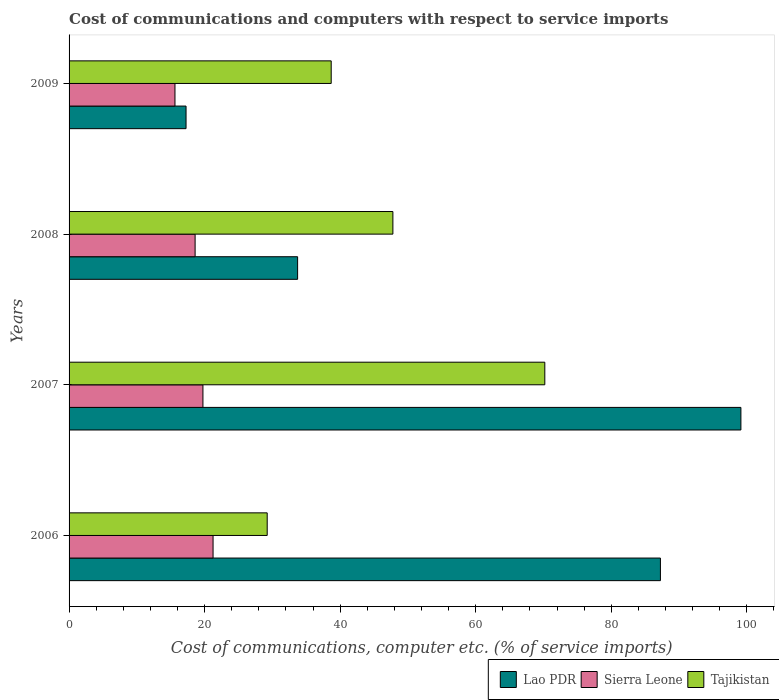How many different coloured bars are there?
Your answer should be compact. 3. Are the number of bars per tick equal to the number of legend labels?
Your answer should be compact. Yes. What is the label of the 4th group of bars from the top?
Provide a succinct answer. 2006. What is the cost of communications and computers in Sierra Leone in 2006?
Keep it short and to the point. 21.25. Across all years, what is the maximum cost of communications and computers in Tajikistan?
Your answer should be compact. 70.2. Across all years, what is the minimum cost of communications and computers in Sierra Leone?
Offer a very short reply. 15.63. In which year was the cost of communications and computers in Tajikistan minimum?
Offer a very short reply. 2006. What is the total cost of communications and computers in Lao PDR in the graph?
Your answer should be compact. 237.36. What is the difference between the cost of communications and computers in Tajikistan in 2006 and that in 2008?
Make the answer very short. -18.55. What is the difference between the cost of communications and computers in Lao PDR in 2006 and the cost of communications and computers in Sierra Leone in 2009?
Provide a short and direct response. 71.63. What is the average cost of communications and computers in Lao PDR per year?
Offer a terse response. 59.34. In the year 2006, what is the difference between the cost of communications and computers in Lao PDR and cost of communications and computers in Sierra Leone?
Make the answer very short. 66.01. What is the ratio of the cost of communications and computers in Lao PDR in 2006 to that in 2008?
Give a very brief answer. 2.59. Is the cost of communications and computers in Tajikistan in 2006 less than that in 2008?
Your answer should be compact. Yes. What is the difference between the highest and the second highest cost of communications and computers in Tajikistan?
Your response must be concise. 22.42. What is the difference between the highest and the lowest cost of communications and computers in Sierra Leone?
Provide a short and direct response. 5.62. In how many years, is the cost of communications and computers in Tajikistan greater than the average cost of communications and computers in Tajikistan taken over all years?
Offer a terse response. 2. What does the 3rd bar from the top in 2009 represents?
Provide a short and direct response. Lao PDR. What does the 1st bar from the bottom in 2008 represents?
Provide a short and direct response. Lao PDR. Are all the bars in the graph horizontal?
Offer a terse response. Yes. How many years are there in the graph?
Provide a short and direct response. 4. Does the graph contain any zero values?
Make the answer very short. No. Does the graph contain grids?
Provide a succinct answer. No. How many legend labels are there?
Provide a short and direct response. 3. What is the title of the graph?
Your answer should be very brief. Cost of communications and computers with respect to service imports. Does "Heavily indebted poor countries" appear as one of the legend labels in the graph?
Offer a very short reply. No. What is the label or title of the X-axis?
Offer a very short reply. Cost of communications, computer etc. (% of service imports). What is the Cost of communications, computer etc. (% of service imports) of Lao PDR in 2006?
Your response must be concise. 87.25. What is the Cost of communications, computer etc. (% of service imports) of Sierra Leone in 2006?
Your answer should be very brief. 21.25. What is the Cost of communications, computer etc. (% of service imports) in Tajikistan in 2006?
Your response must be concise. 29.23. What is the Cost of communications, computer etc. (% of service imports) of Lao PDR in 2007?
Offer a very short reply. 99.13. What is the Cost of communications, computer etc. (% of service imports) in Sierra Leone in 2007?
Provide a succinct answer. 19.75. What is the Cost of communications, computer etc. (% of service imports) in Tajikistan in 2007?
Your response must be concise. 70.2. What is the Cost of communications, computer etc. (% of service imports) of Lao PDR in 2008?
Ensure brevity in your answer.  33.72. What is the Cost of communications, computer etc. (% of service imports) in Sierra Leone in 2008?
Your answer should be compact. 18.6. What is the Cost of communications, computer etc. (% of service imports) in Tajikistan in 2008?
Offer a very short reply. 47.78. What is the Cost of communications, computer etc. (% of service imports) in Lao PDR in 2009?
Your response must be concise. 17.26. What is the Cost of communications, computer etc. (% of service imports) in Sierra Leone in 2009?
Provide a short and direct response. 15.63. What is the Cost of communications, computer etc. (% of service imports) in Tajikistan in 2009?
Offer a very short reply. 38.68. Across all years, what is the maximum Cost of communications, computer etc. (% of service imports) in Lao PDR?
Ensure brevity in your answer.  99.13. Across all years, what is the maximum Cost of communications, computer etc. (% of service imports) in Sierra Leone?
Offer a terse response. 21.25. Across all years, what is the maximum Cost of communications, computer etc. (% of service imports) of Tajikistan?
Your response must be concise. 70.2. Across all years, what is the minimum Cost of communications, computer etc. (% of service imports) of Lao PDR?
Make the answer very short. 17.26. Across all years, what is the minimum Cost of communications, computer etc. (% of service imports) of Sierra Leone?
Keep it short and to the point. 15.63. Across all years, what is the minimum Cost of communications, computer etc. (% of service imports) in Tajikistan?
Make the answer very short. 29.23. What is the total Cost of communications, computer etc. (% of service imports) in Lao PDR in the graph?
Offer a terse response. 237.36. What is the total Cost of communications, computer etc. (% of service imports) of Sierra Leone in the graph?
Give a very brief answer. 75.22. What is the total Cost of communications, computer etc. (% of service imports) in Tajikistan in the graph?
Your answer should be very brief. 185.89. What is the difference between the Cost of communications, computer etc. (% of service imports) in Lao PDR in 2006 and that in 2007?
Make the answer very short. -11.88. What is the difference between the Cost of communications, computer etc. (% of service imports) of Sierra Leone in 2006 and that in 2007?
Provide a short and direct response. 1.49. What is the difference between the Cost of communications, computer etc. (% of service imports) of Tajikistan in 2006 and that in 2007?
Your answer should be very brief. -40.96. What is the difference between the Cost of communications, computer etc. (% of service imports) in Lao PDR in 2006 and that in 2008?
Give a very brief answer. 53.53. What is the difference between the Cost of communications, computer etc. (% of service imports) of Sierra Leone in 2006 and that in 2008?
Your answer should be compact. 2.65. What is the difference between the Cost of communications, computer etc. (% of service imports) in Tajikistan in 2006 and that in 2008?
Offer a very short reply. -18.55. What is the difference between the Cost of communications, computer etc. (% of service imports) of Lao PDR in 2006 and that in 2009?
Your response must be concise. 69.99. What is the difference between the Cost of communications, computer etc. (% of service imports) of Sierra Leone in 2006 and that in 2009?
Your answer should be very brief. 5.62. What is the difference between the Cost of communications, computer etc. (% of service imports) of Tajikistan in 2006 and that in 2009?
Give a very brief answer. -9.44. What is the difference between the Cost of communications, computer etc. (% of service imports) of Lao PDR in 2007 and that in 2008?
Ensure brevity in your answer.  65.41. What is the difference between the Cost of communications, computer etc. (% of service imports) of Sierra Leone in 2007 and that in 2008?
Your answer should be compact. 1.16. What is the difference between the Cost of communications, computer etc. (% of service imports) in Tajikistan in 2007 and that in 2008?
Offer a terse response. 22.42. What is the difference between the Cost of communications, computer etc. (% of service imports) in Lao PDR in 2007 and that in 2009?
Your answer should be compact. 81.87. What is the difference between the Cost of communications, computer etc. (% of service imports) in Sierra Leone in 2007 and that in 2009?
Keep it short and to the point. 4.13. What is the difference between the Cost of communications, computer etc. (% of service imports) of Tajikistan in 2007 and that in 2009?
Keep it short and to the point. 31.52. What is the difference between the Cost of communications, computer etc. (% of service imports) of Lao PDR in 2008 and that in 2009?
Provide a short and direct response. 16.46. What is the difference between the Cost of communications, computer etc. (% of service imports) in Sierra Leone in 2008 and that in 2009?
Your response must be concise. 2.97. What is the difference between the Cost of communications, computer etc. (% of service imports) in Tajikistan in 2008 and that in 2009?
Provide a short and direct response. 9.1. What is the difference between the Cost of communications, computer etc. (% of service imports) in Lao PDR in 2006 and the Cost of communications, computer etc. (% of service imports) in Sierra Leone in 2007?
Provide a short and direct response. 67.5. What is the difference between the Cost of communications, computer etc. (% of service imports) of Lao PDR in 2006 and the Cost of communications, computer etc. (% of service imports) of Tajikistan in 2007?
Provide a succinct answer. 17.06. What is the difference between the Cost of communications, computer etc. (% of service imports) in Sierra Leone in 2006 and the Cost of communications, computer etc. (% of service imports) in Tajikistan in 2007?
Provide a short and direct response. -48.95. What is the difference between the Cost of communications, computer etc. (% of service imports) of Lao PDR in 2006 and the Cost of communications, computer etc. (% of service imports) of Sierra Leone in 2008?
Your answer should be compact. 68.66. What is the difference between the Cost of communications, computer etc. (% of service imports) of Lao PDR in 2006 and the Cost of communications, computer etc. (% of service imports) of Tajikistan in 2008?
Give a very brief answer. 39.47. What is the difference between the Cost of communications, computer etc. (% of service imports) in Sierra Leone in 2006 and the Cost of communications, computer etc. (% of service imports) in Tajikistan in 2008?
Make the answer very short. -26.53. What is the difference between the Cost of communications, computer etc. (% of service imports) of Lao PDR in 2006 and the Cost of communications, computer etc. (% of service imports) of Sierra Leone in 2009?
Offer a terse response. 71.63. What is the difference between the Cost of communications, computer etc. (% of service imports) of Lao PDR in 2006 and the Cost of communications, computer etc. (% of service imports) of Tajikistan in 2009?
Make the answer very short. 48.57. What is the difference between the Cost of communications, computer etc. (% of service imports) of Sierra Leone in 2006 and the Cost of communications, computer etc. (% of service imports) of Tajikistan in 2009?
Ensure brevity in your answer.  -17.43. What is the difference between the Cost of communications, computer etc. (% of service imports) in Lao PDR in 2007 and the Cost of communications, computer etc. (% of service imports) in Sierra Leone in 2008?
Make the answer very short. 80.53. What is the difference between the Cost of communications, computer etc. (% of service imports) in Lao PDR in 2007 and the Cost of communications, computer etc. (% of service imports) in Tajikistan in 2008?
Offer a very short reply. 51.35. What is the difference between the Cost of communications, computer etc. (% of service imports) of Sierra Leone in 2007 and the Cost of communications, computer etc. (% of service imports) of Tajikistan in 2008?
Your answer should be compact. -28.03. What is the difference between the Cost of communications, computer etc. (% of service imports) in Lao PDR in 2007 and the Cost of communications, computer etc. (% of service imports) in Sierra Leone in 2009?
Keep it short and to the point. 83.5. What is the difference between the Cost of communications, computer etc. (% of service imports) in Lao PDR in 2007 and the Cost of communications, computer etc. (% of service imports) in Tajikistan in 2009?
Provide a succinct answer. 60.45. What is the difference between the Cost of communications, computer etc. (% of service imports) of Sierra Leone in 2007 and the Cost of communications, computer etc. (% of service imports) of Tajikistan in 2009?
Provide a short and direct response. -18.93. What is the difference between the Cost of communications, computer etc. (% of service imports) in Lao PDR in 2008 and the Cost of communications, computer etc. (% of service imports) in Sierra Leone in 2009?
Your answer should be very brief. 18.09. What is the difference between the Cost of communications, computer etc. (% of service imports) of Lao PDR in 2008 and the Cost of communications, computer etc. (% of service imports) of Tajikistan in 2009?
Ensure brevity in your answer.  -4.96. What is the difference between the Cost of communications, computer etc. (% of service imports) in Sierra Leone in 2008 and the Cost of communications, computer etc. (% of service imports) in Tajikistan in 2009?
Offer a very short reply. -20.08. What is the average Cost of communications, computer etc. (% of service imports) of Lao PDR per year?
Your answer should be compact. 59.34. What is the average Cost of communications, computer etc. (% of service imports) in Sierra Leone per year?
Make the answer very short. 18.81. What is the average Cost of communications, computer etc. (% of service imports) in Tajikistan per year?
Provide a succinct answer. 46.47. In the year 2006, what is the difference between the Cost of communications, computer etc. (% of service imports) in Lao PDR and Cost of communications, computer etc. (% of service imports) in Sierra Leone?
Keep it short and to the point. 66.01. In the year 2006, what is the difference between the Cost of communications, computer etc. (% of service imports) of Lao PDR and Cost of communications, computer etc. (% of service imports) of Tajikistan?
Offer a terse response. 58.02. In the year 2006, what is the difference between the Cost of communications, computer etc. (% of service imports) in Sierra Leone and Cost of communications, computer etc. (% of service imports) in Tajikistan?
Your answer should be compact. -7.99. In the year 2007, what is the difference between the Cost of communications, computer etc. (% of service imports) in Lao PDR and Cost of communications, computer etc. (% of service imports) in Sierra Leone?
Make the answer very short. 79.38. In the year 2007, what is the difference between the Cost of communications, computer etc. (% of service imports) of Lao PDR and Cost of communications, computer etc. (% of service imports) of Tajikistan?
Give a very brief answer. 28.93. In the year 2007, what is the difference between the Cost of communications, computer etc. (% of service imports) in Sierra Leone and Cost of communications, computer etc. (% of service imports) in Tajikistan?
Give a very brief answer. -50.44. In the year 2008, what is the difference between the Cost of communications, computer etc. (% of service imports) of Lao PDR and Cost of communications, computer etc. (% of service imports) of Sierra Leone?
Provide a succinct answer. 15.12. In the year 2008, what is the difference between the Cost of communications, computer etc. (% of service imports) of Lao PDR and Cost of communications, computer etc. (% of service imports) of Tajikistan?
Keep it short and to the point. -14.06. In the year 2008, what is the difference between the Cost of communications, computer etc. (% of service imports) of Sierra Leone and Cost of communications, computer etc. (% of service imports) of Tajikistan?
Your answer should be compact. -29.18. In the year 2009, what is the difference between the Cost of communications, computer etc. (% of service imports) in Lao PDR and Cost of communications, computer etc. (% of service imports) in Sierra Leone?
Your answer should be compact. 1.63. In the year 2009, what is the difference between the Cost of communications, computer etc. (% of service imports) of Lao PDR and Cost of communications, computer etc. (% of service imports) of Tajikistan?
Offer a terse response. -21.42. In the year 2009, what is the difference between the Cost of communications, computer etc. (% of service imports) in Sierra Leone and Cost of communications, computer etc. (% of service imports) in Tajikistan?
Your answer should be very brief. -23.05. What is the ratio of the Cost of communications, computer etc. (% of service imports) in Lao PDR in 2006 to that in 2007?
Make the answer very short. 0.88. What is the ratio of the Cost of communications, computer etc. (% of service imports) in Sierra Leone in 2006 to that in 2007?
Ensure brevity in your answer.  1.08. What is the ratio of the Cost of communications, computer etc. (% of service imports) of Tajikistan in 2006 to that in 2007?
Give a very brief answer. 0.42. What is the ratio of the Cost of communications, computer etc. (% of service imports) in Lao PDR in 2006 to that in 2008?
Your answer should be very brief. 2.59. What is the ratio of the Cost of communications, computer etc. (% of service imports) of Sierra Leone in 2006 to that in 2008?
Your response must be concise. 1.14. What is the ratio of the Cost of communications, computer etc. (% of service imports) in Tajikistan in 2006 to that in 2008?
Offer a terse response. 0.61. What is the ratio of the Cost of communications, computer etc. (% of service imports) in Lao PDR in 2006 to that in 2009?
Offer a terse response. 5.05. What is the ratio of the Cost of communications, computer etc. (% of service imports) of Sierra Leone in 2006 to that in 2009?
Your answer should be compact. 1.36. What is the ratio of the Cost of communications, computer etc. (% of service imports) in Tajikistan in 2006 to that in 2009?
Provide a succinct answer. 0.76. What is the ratio of the Cost of communications, computer etc. (% of service imports) in Lao PDR in 2007 to that in 2008?
Your answer should be compact. 2.94. What is the ratio of the Cost of communications, computer etc. (% of service imports) of Sierra Leone in 2007 to that in 2008?
Offer a terse response. 1.06. What is the ratio of the Cost of communications, computer etc. (% of service imports) of Tajikistan in 2007 to that in 2008?
Keep it short and to the point. 1.47. What is the ratio of the Cost of communications, computer etc. (% of service imports) of Lao PDR in 2007 to that in 2009?
Make the answer very short. 5.74. What is the ratio of the Cost of communications, computer etc. (% of service imports) of Sierra Leone in 2007 to that in 2009?
Ensure brevity in your answer.  1.26. What is the ratio of the Cost of communications, computer etc. (% of service imports) of Tajikistan in 2007 to that in 2009?
Your response must be concise. 1.81. What is the ratio of the Cost of communications, computer etc. (% of service imports) of Lao PDR in 2008 to that in 2009?
Your answer should be compact. 1.95. What is the ratio of the Cost of communications, computer etc. (% of service imports) of Sierra Leone in 2008 to that in 2009?
Provide a short and direct response. 1.19. What is the ratio of the Cost of communications, computer etc. (% of service imports) in Tajikistan in 2008 to that in 2009?
Your answer should be compact. 1.24. What is the difference between the highest and the second highest Cost of communications, computer etc. (% of service imports) of Lao PDR?
Keep it short and to the point. 11.88. What is the difference between the highest and the second highest Cost of communications, computer etc. (% of service imports) of Sierra Leone?
Your answer should be very brief. 1.49. What is the difference between the highest and the second highest Cost of communications, computer etc. (% of service imports) of Tajikistan?
Your answer should be very brief. 22.42. What is the difference between the highest and the lowest Cost of communications, computer etc. (% of service imports) in Lao PDR?
Provide a succinct answer. 81.87. What is the difference between the highest and the lowest Cost of communications, computer etc. (% of service imports) of Sierra Leone?
Keep it short and to the point. 5.62. What is the difference between the highest and the lowest Cost of communications, computer etc. (% of service imports) in Tajikistan?
Provide a succinct answer. 40.96. 